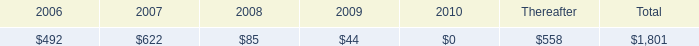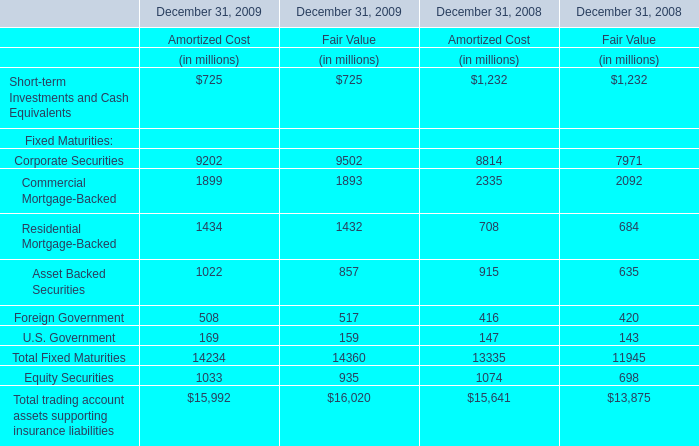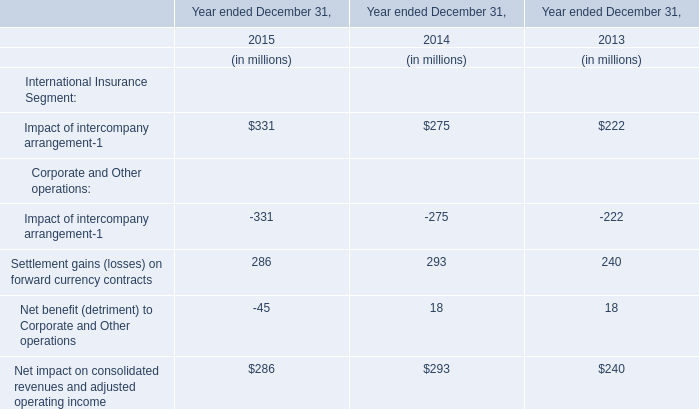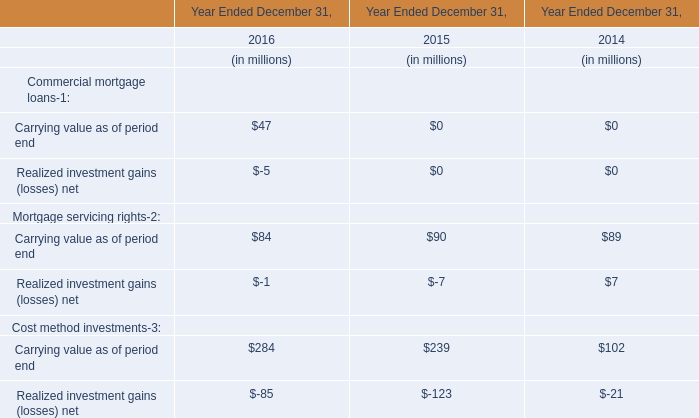What's the increasing rate of the Fair Value on December 31 for Equity Securities in 2009? 
Computations: ((935 - 698) / 698)
Answer: 0.33954. 